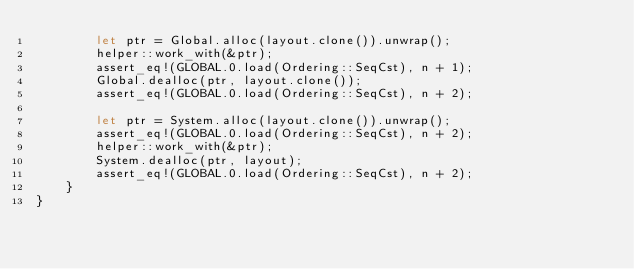Convert code to text. <code><loc_0><loc_0><loc_500><loc_500><_Rust_>        let ptr = Global.alloc(layout.clone()).unwrap();
        helper::work_with(&ptr);
        assert_eq!(GLOBAL.0.load(Ordering::SeqCst), n + 1);
        Global.dealloc(ptr, layout.clone());
        assert_eq!(GLOBAL.0.load(Ordering::SeqCst), n + 2);

        let ptr = System.alloc(layout.clone()).unwrap();
        assert_eq!(GLOBAL.0.load(Ordering::SeqCst), n + 2);
        helper::work_with(&ptr);
        System.dealloc(ptr, layout);
        assert_eq!(GLOBAL.0.load(Ordering::SeqCst), n + 2);
    }
}
</code> 